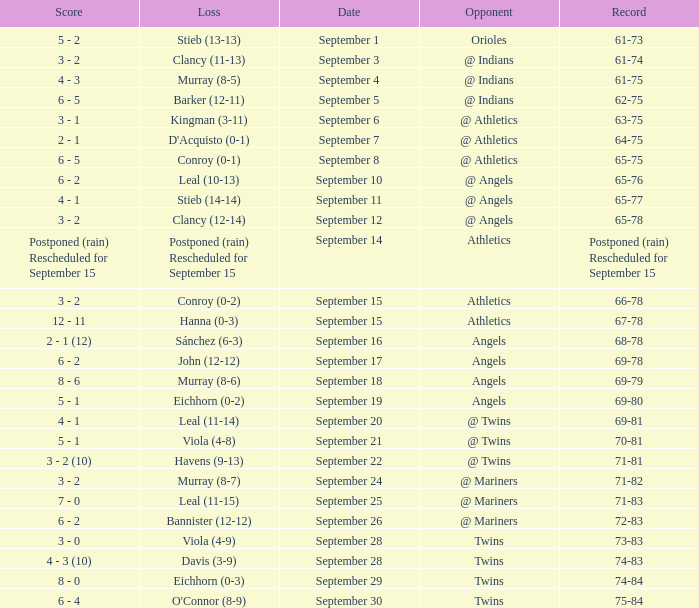Name the score for september 11 4 - 1. 